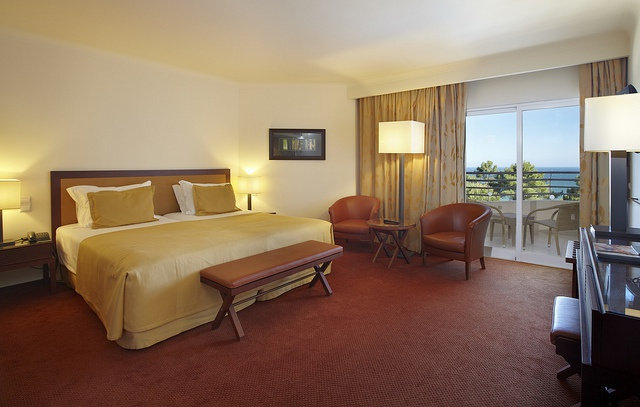Describe the objects in this image and their specific colors. I can see bed in tan, olive, and maroon tones, chair in tan, maroon, black, and brown tones, chair in tan, maroon, brown, and black tones, chair in tan and gray tones, and chair in tan, gray, and darkgray tones in this image. 